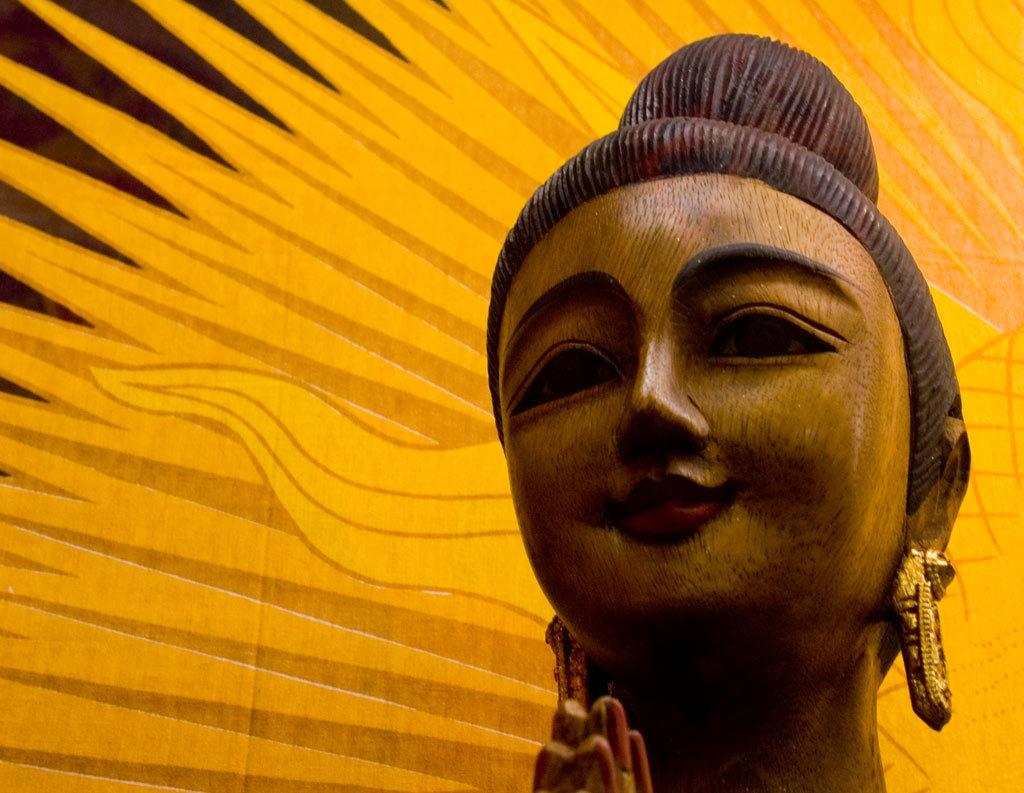What is the main subject of the image? There is a sculpture in the image. What part of the sculpture can be seen in the image? The face of the sculpture is visible. Can you describe the background color in the image? The background color is yellow and brown. What type of zebra can be seen interacting with the sculpture in the image? There is no zebra present in the image, and therefore no such interaction can be observed. 